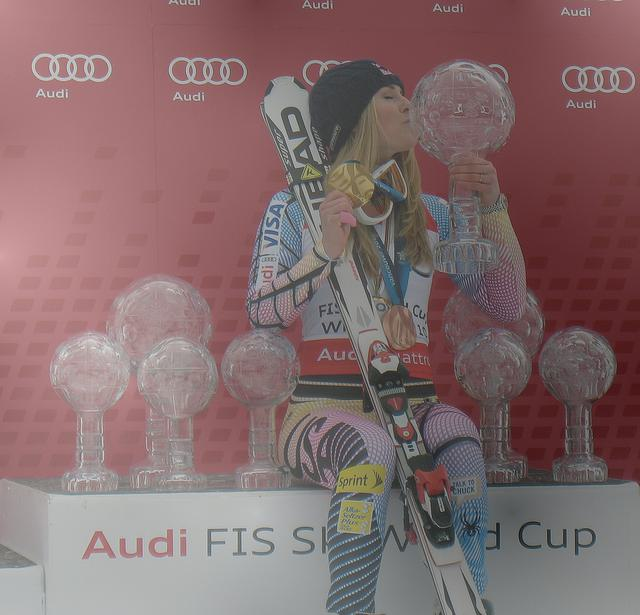Is the subject in the image clear and identifiable?
A. No
B. Yes
Answer with the option's letter from the given choices directly.
 B. 